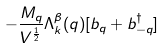Convert formula to latex. <formula><loc_0><loc_0><loc_500><loc_500>- \frac { M _ { q } } { V ^ { \frac { 1 } { 2 } } } \Lambda ^ { \beta } _ { k } ( { q } ) [ b _ { q } + b ^ { \dagger } _ { - { q } } ]</formula> 